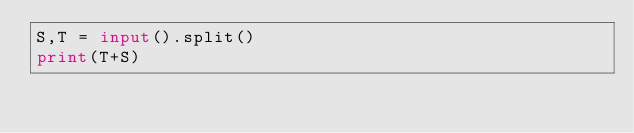<code> <loc_0><loc_0><loc_500><loc_500><_Python_>S,T = input().split()
print(T+S)</code> 